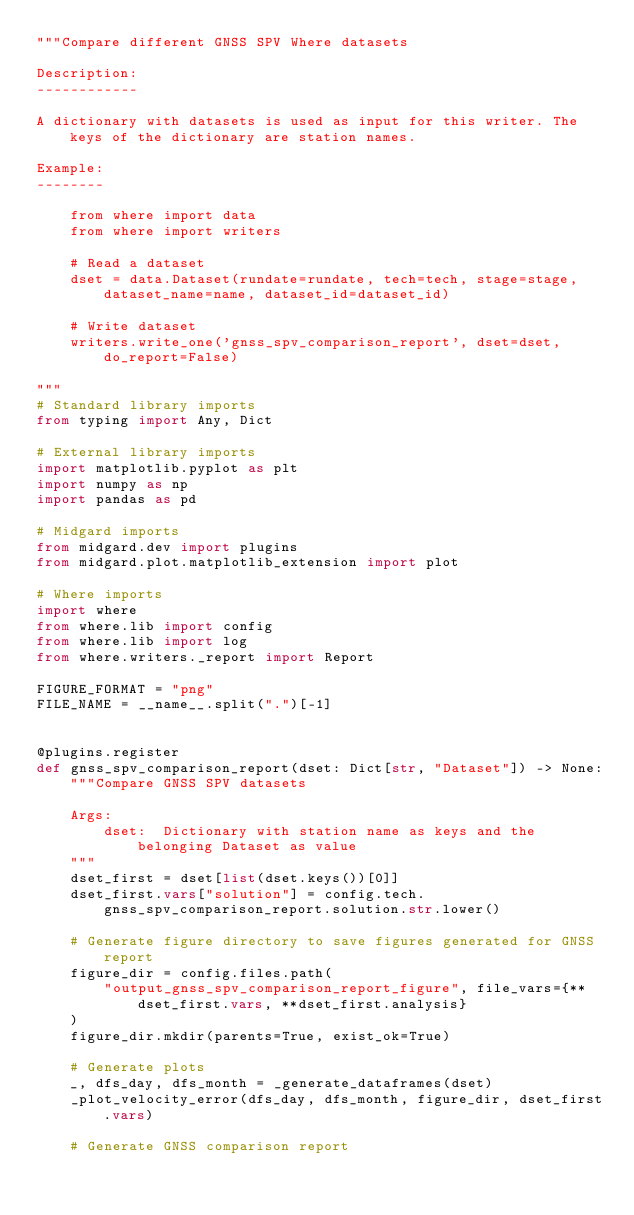<code> <loc_0><loc_0><loc_500><loc_500><_Python_>"""Compare different GNSS SPV Where datasets

Description:
------------

A dictionary with datasets is used as input for this writer. The keys of the dictionary are station names. 

Example:
--------

    from where import data
    from where import writers

    # Read a dataset
    dset = data.Dataset(rundate=rundate, tech=tech, stage=stage, dataset_name=name, dataset_id=dataset_id)

    # Write dataset
    writers.write_one('gnss_spv_comparison_report', dset=dset, do_report=False)

"""
# Standard library imports
from typing import Any, Dict

# External library imports
import matplotlib.pyplot as plt
import numpy as np
import pandas as pd

# Midgard imports
from midgard.dev import plugins
from midgard.plot.matplotlib_extension import plot

# Where imports
import where
from where.lib import config
from where.lib import log
from where.writers._report import Report

FIGURE_FORMAT = "png"
FILE_NAME = __name__.split(".")[-1]


@plugins.register
def gnss_spv_comparison_report(dset: Dict[str, "Dataset"]) -> None:
    """Compare GNSS SPV datasets

    Args:
        dset:  Dictionary with station name as keys and the belonging Dataset as value
    """
    dset_first = dset[list(dset.keys())[0]]
    dset_first.vars["solution"] = config.tech.gnss_spv_comparison_report.solution.str.lower()

    # Generate figure directory to save figures generated for GNSS report
    figure_dir = config.files.path(
        "output_gnss_spv_comparison_report_figure", file_vars={**dset_first.vars, **dset_first.analysis}
    )
    figure_dir.mkdir(parents=True, exist_ok=True)

    # Generate plots
    _, dfs_day, dfs_month = _generate_dataframes(dset)
    _plot_velocity_error(dfs_day, dfs_month, figure_dir, dset_first.vars)

    # Generate GNSS comparison report</code> 